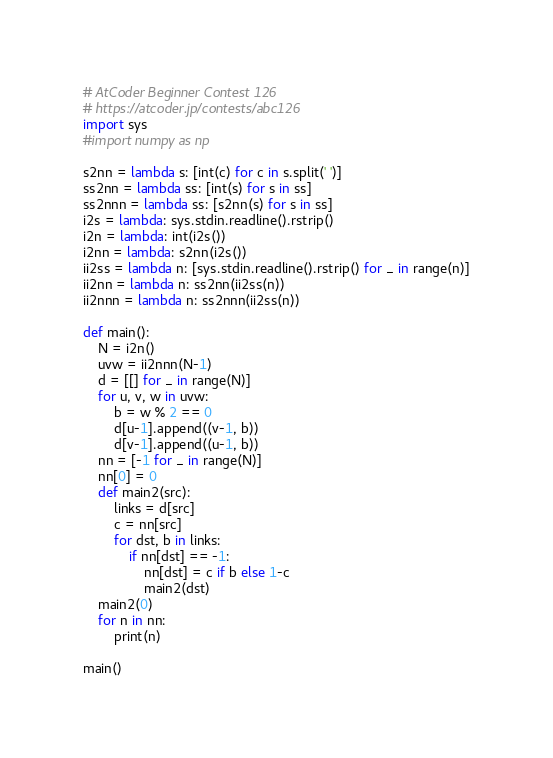<code> <loc_0><loc_0><loc_500><loc_500><_Python_># AtCoder Beginner Contest 126
# https://atcoder.jp/contests/abc126
import sys
#import numpy as np

s2nn = lambda s: [int(c) for c in s.split(' ')]
ss2nn = lambda ss: [int(s) for s in ss]
ss2nnn = lambda ss: [s2nn(s) for s in ss]
i2s = lambda: sys.stdin.readline().rstrip()
i2n = lambda: int(i2s())
i2nn = lambda: s2nn(i2s())
ii2ss = lambda n: [sys.stdin.readline().rstrip() for _ in range(n)]
ii2nn = lambda n: ss2nn(ii2ss(n))
ii2nnn = lambda n: ss2nnn(ii2ss(n))

def main():
    N = i2n()
    uvw = ii2nnn(N-1)
    d = [[] for _ in range(N)]
    for u, v, w in uvw:
        b = w % 2 == 0
        d[u-1].append((v-1, b))
        d[v-1].append((u-1, b))
    nn = [-1 for _ in range(N)]
    nn[0] = 0
    def main2(src):
        links = d[src]
        c = nn[src]
        for dst, b in links:
            if nn[dst] == -1:
                nn[dst] = c if b else 1-c
                main2(dst)
    main2(0)
    for n in nn:
        print(n)

main()
</code> 